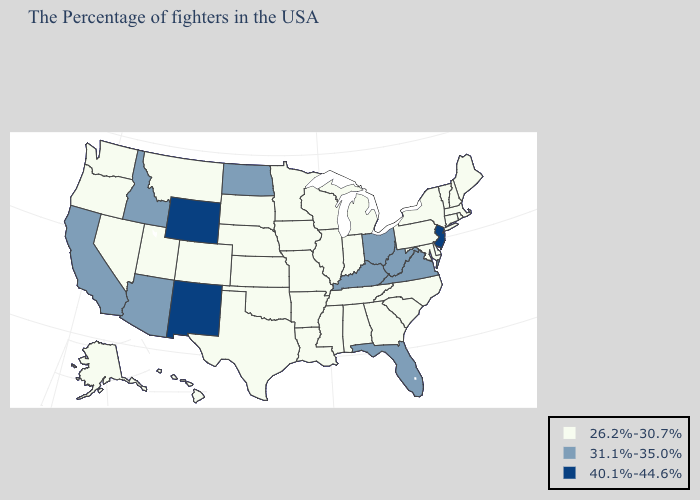Does Washington have the lowest value in the West?
Write a very short answer. Yes. Name the states that have a value in the range 26.2%-30.7%?
Answer briefly. Maine, Massachusetts, Rhode Island, New Hampshire, Vermont, Connecticut, New York, Delaware, Maryland, Pennsylvania, North Carolina, South Carolina, Georgia, Michigan, Indiana, Alabama, Tennessee, Wisconsin, Illinois, Mississippi, Louisiana, Missouri, Arkansas, Minnesota, Iowa, Kansas, Nebraska, Oklahoma, Texas, South Dakota, Colorado, Utah, Montana, Nevada, Washington, Oregon, Alaska, Hawaii. Name the states that have a value in the range 31.1%-35.0%?
Short answer required. Virginia, West Virginia, Ohio, Florida, Kentucky, North Dakota, Arizona, Idaho, California. Does Massachusetts have the highest value in the Northeast?
Concise answer only. No. Name the states that have a value in the range 40.1%-44.6%?
Be succinct. New Jersey, Wyoming, New Mexico. Name the states that have a value in the range 40.1%-44.6%?
Give a very brief answer. New Jersey, Wyoming, New Mexico. What is the value of Mississippi?
Quick response, please. 26.2%-30.7%. What is the value of Maryland?
Quick response, please. 26.2%-30.7%. Does Massachusetts have the highest value in the Northeast?
Write a very short answer. No. Does Georgia have the lowest value in the USA?
Be succinct. Yes. Name the states that have a value in the range 31.1%-35.0%?
Short answer required. Virginia, West Virginia, Ohio, Florida, Kentucky, North Dakota, Arizona, Idaho, California. Does the first symbol in the legend represent the smallest category?
Give a very brief answer. Yes. Does the map have missing data?
Concise answer only. No. What is the lowest value in the USA?
Short answer required. 26.2%-30.7%. Name the states that have a value in the range 31.1%-35.0%?
Be succinct. Virginia, West Virginia, Ohio, Florida, Kentucky, North Dakota, Arizona, Idaho, California. 